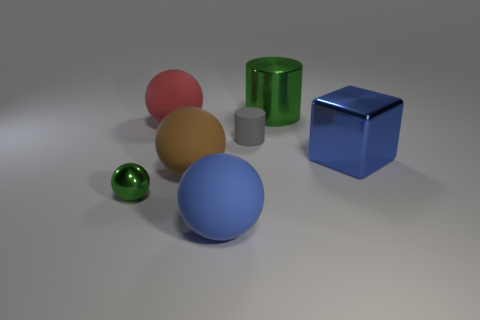Which object appears to be the most reflective? The object that shows the most reflectivity is the small green sphere; you can see the light and environment reflecting off its surface quite clearly. 